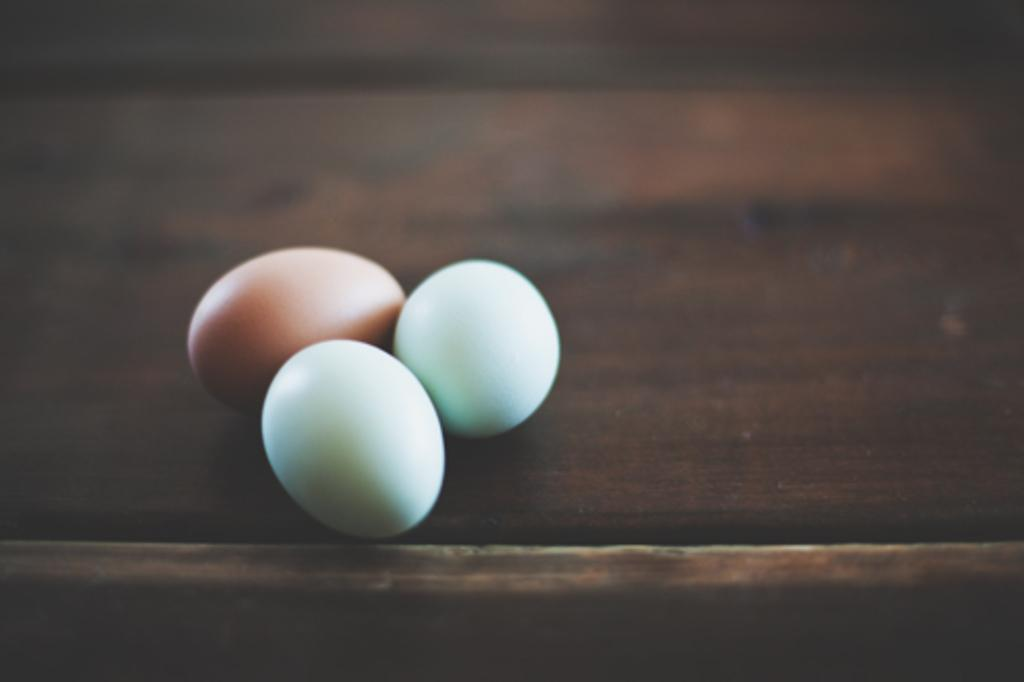How many objects are on the wooden table in the image? There are three objects on the wooden table in the image. Is there a collar visible on any of the objects on the table in the image? There is no collar present on any of the objects on the table in the image. 